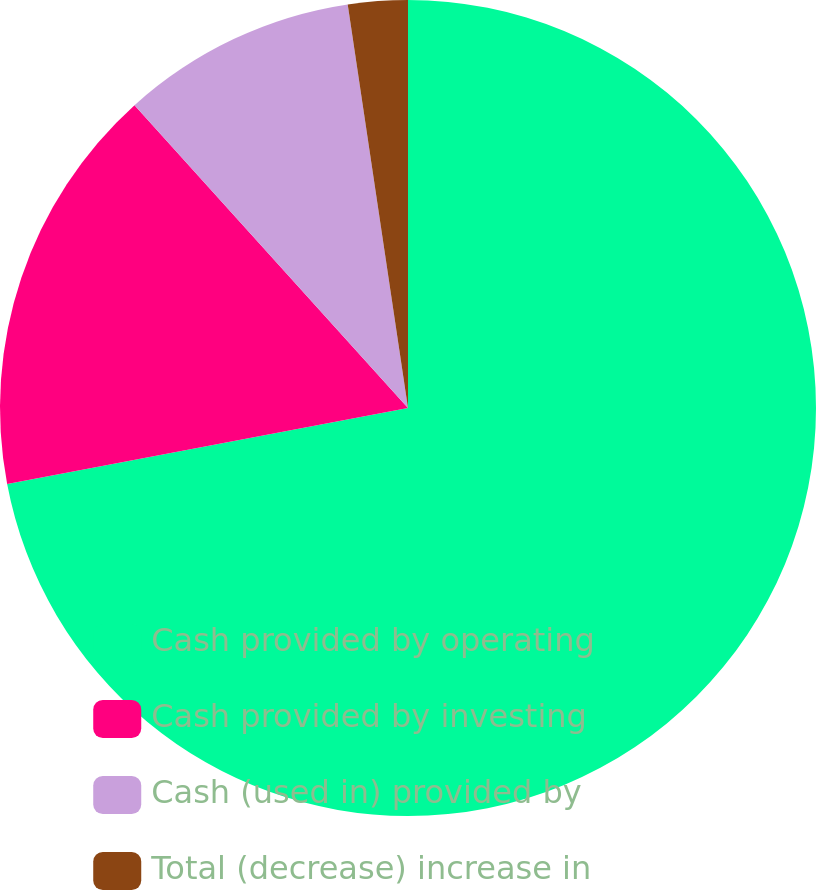<chart> <loc_0><loc_0><loc_500><loc_500><pie_chart><fcel>Cash provided by operating<fcel>Cash provided by investing<fcel>Cash (used in) provided by<fcel>Total (decrease) increase in<nl><fcel>72.01%<fcel>16.29%<fcel>9.33%<fcel>2.36%<nl></chart> 